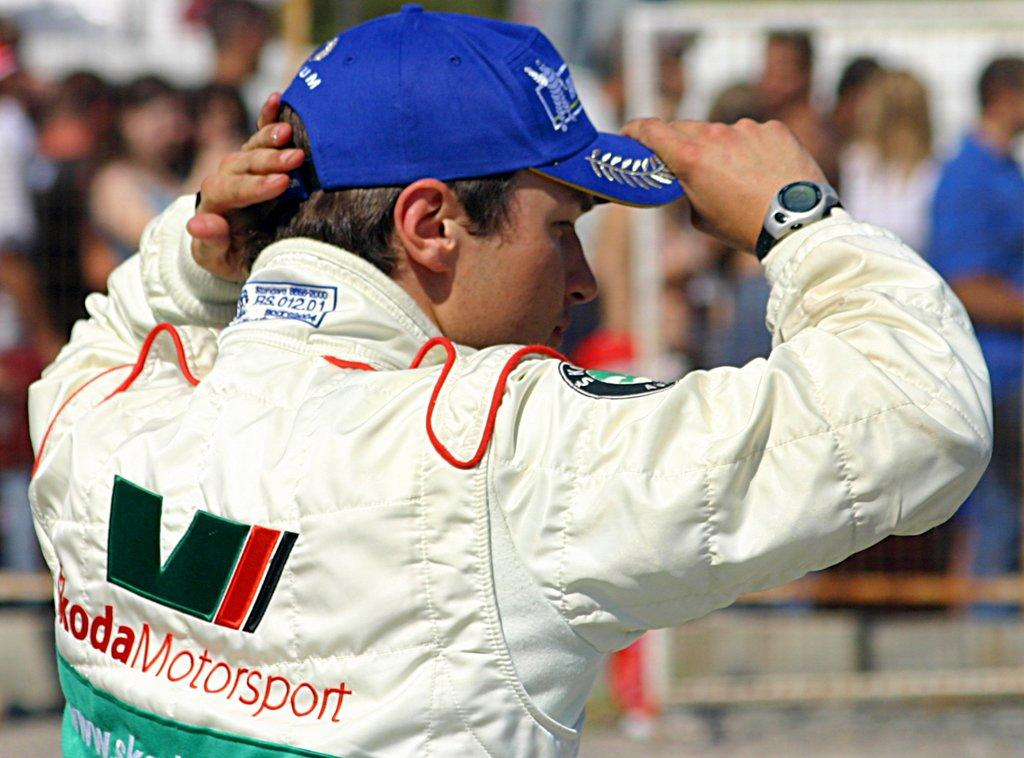<image>
Relay a brief, clear account of the picture shown. a man in a blue hat at a race with the word Motorsport on it 